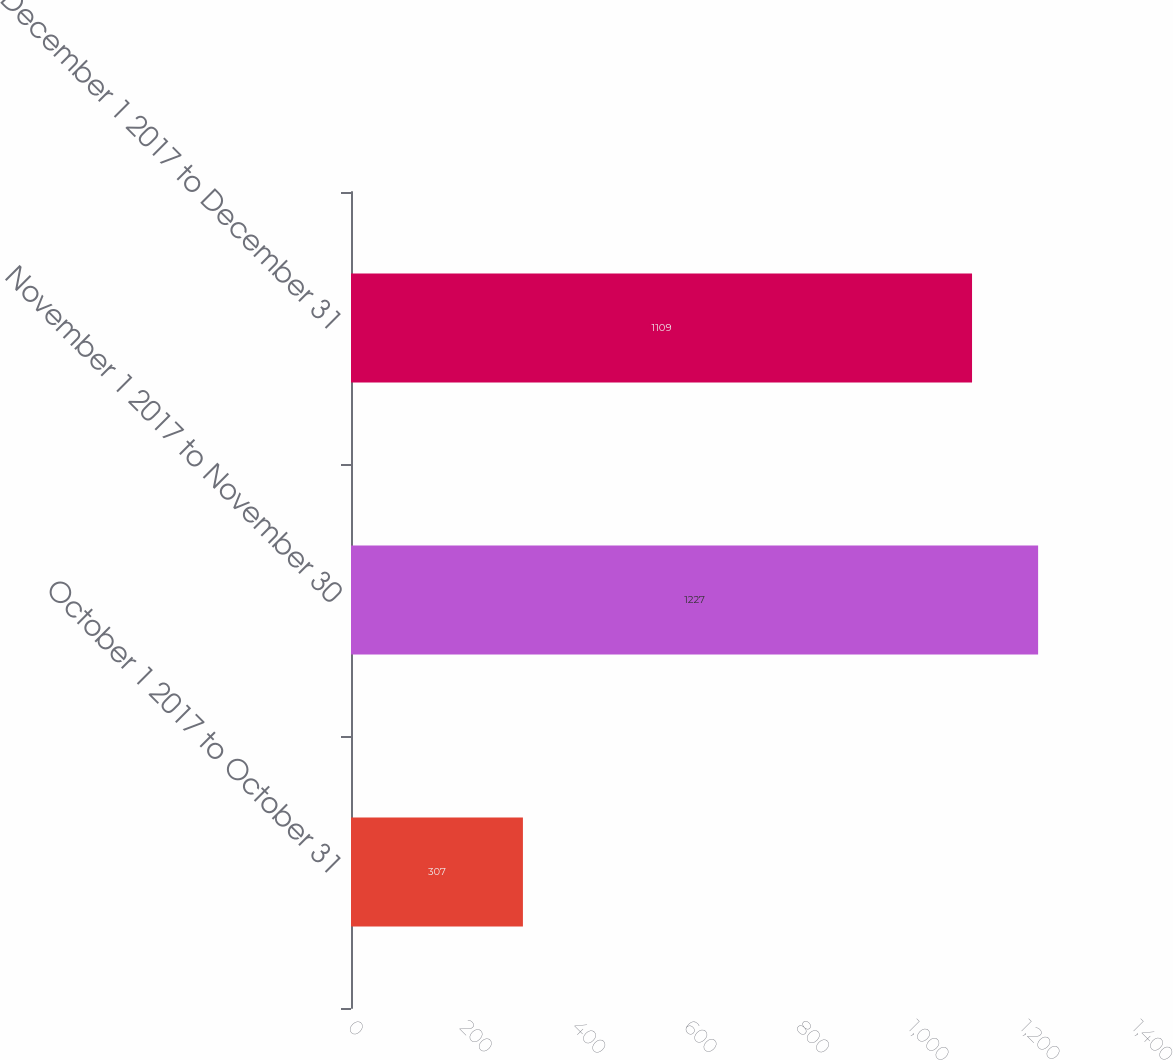Convert chart. <chart><loc_0><loc_0><loc_500><loc_500><bar_chart><fcel>October 1 2017 to October 31<fcel>November 1 2017 to November 30<fcel>December 1 2017 to December 31<nl><fcel>307<fcel>1227<fcel>1109<nl></chart> 